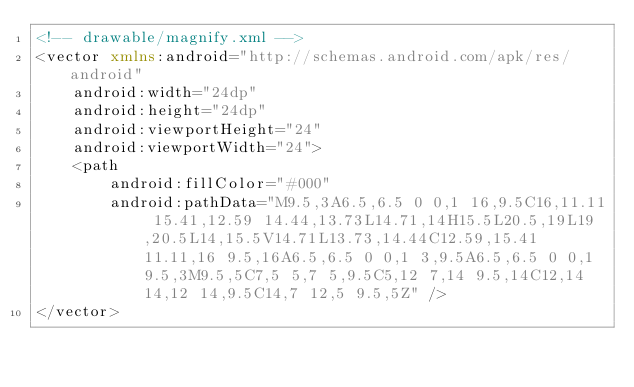<code> <loc_0><loc_0><loc_500><loc_500><_XML_><!-- drawable/magnify.xml -->
<vector xmlns:android="http://schemas.android.com/apk/res/android"
    android:width="24dp"
    android:height="24dp"
    android:viewportHeight="24"
    android:viewportWidth="24">
    <path
        android:fillColor="#000"
        android:pathData="M9.5,3A6.5,6.5 0 0,1 16,9.5C16,11.11 15.41,12.59 14.44,13.73L14.71,14H15.5L20.5,19L19,20.5L14,15.5V14.71L13.73,14.44C12.59,15.41 11.11,16 9.5,16A6.5,6.5 0 0,1 3,9.5A6.5,6.5 0 0,1 9.5,3M9.5,5C7,5 5,7 5,9.5C5,12 7,14 9.5,14C12,14 14,12 14,9.5C14,7 12,5 9.5,5Z" />
</vector></code> 